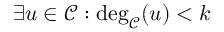<formula> <loc_0><loc_0><loc_500><loc_500>\exists u \in \mathcal { C } \colon \deg _ { \mathcal { C } } ( u ) < k</formula> 